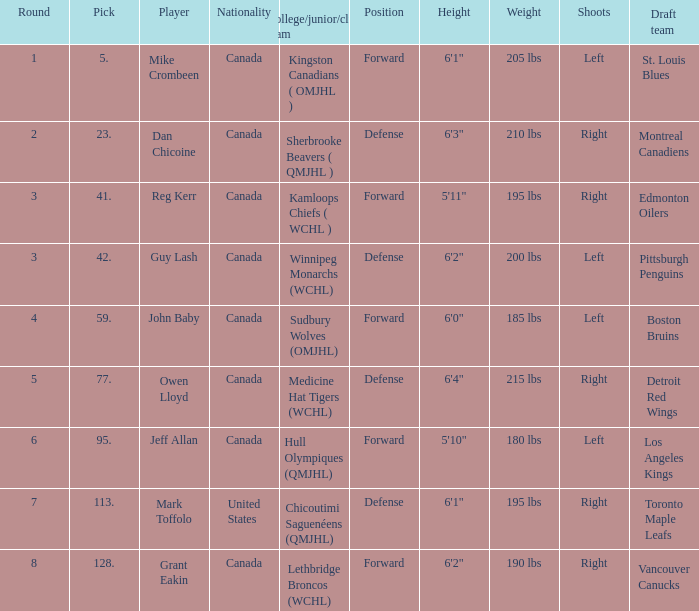Which Round has a Player of dan chicoine, and a Pick larger than 23? None. 